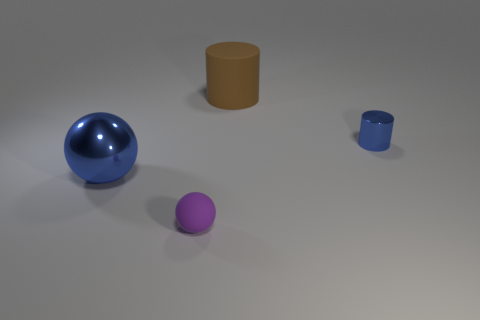What materials are visible in the scene, and how does the lighting affect their appearance? The image showcases various objects with different materials. There is a large glossy blue sphere and a smaller matte purple sphere. Additionally, two cylinders are present; one is matte beige, and the other is a smaller shiny blue. The scene is lit in a way that creates subtle shadows and reflections, particularly noticeable on the glossy surfaces, where it amplifies their shininess and gives depth to the image. 